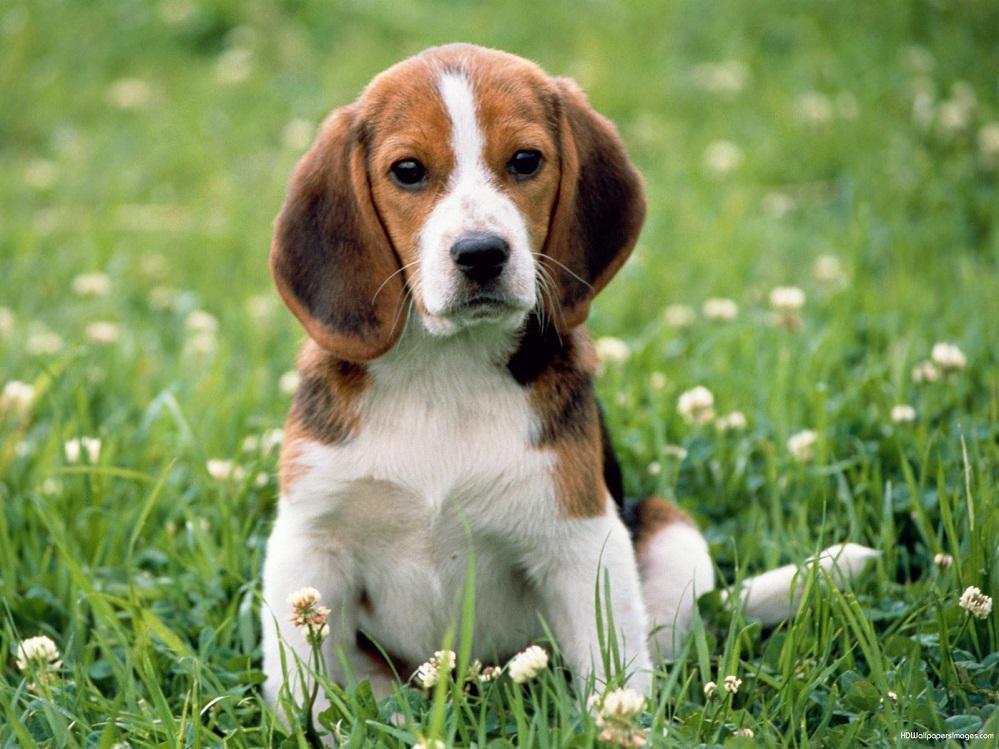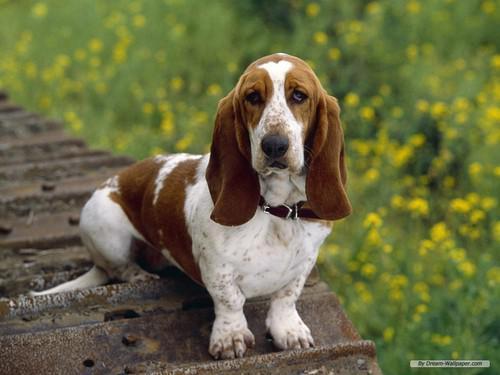The first image is the image on the left, the second image is the image on the right. Assess this claim about the two images: "In one of the images there is a single beagle standing outside.". Correct or not? Answer yes or no. No. 